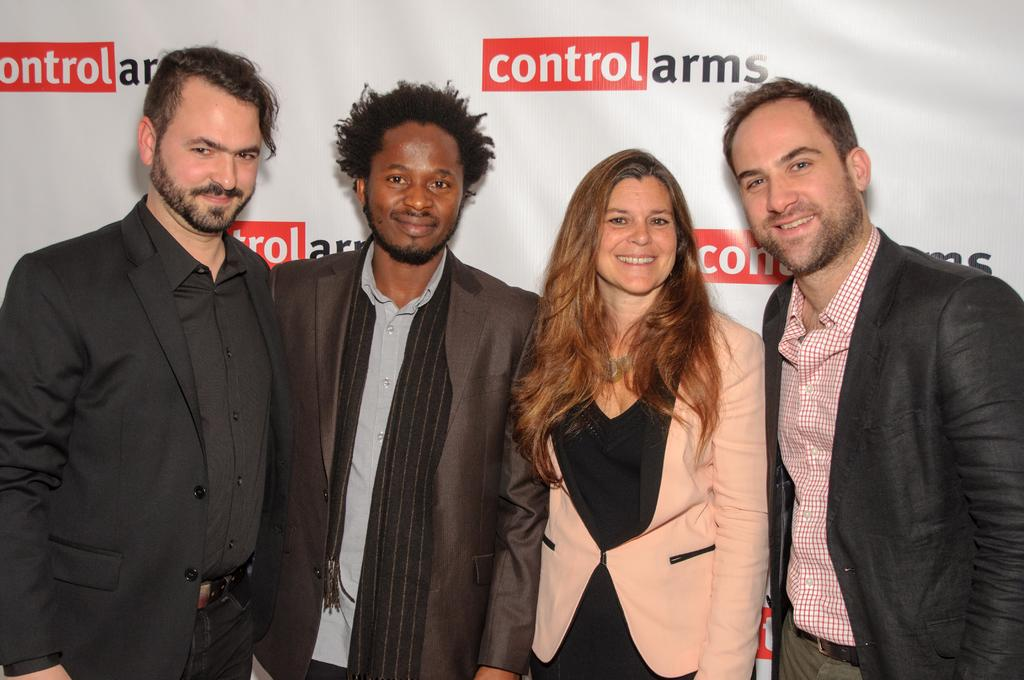How many people are in the image? There are four persons in the image. What are the people wearing? The persons are wearing different color dresses. What is the facial expression of the people in the image? The persons are smiling. What position are the people in? The persons are standing. What can be seen in the background of the image? In the background, there is a white color banner. What colors are used on the banner? The banner has white and black color texts on it. What type of garden can be seen in the image? There is no garden present in the image; it features four people wearing different color dresses, smiling, and standing, with a white banner in the background. 